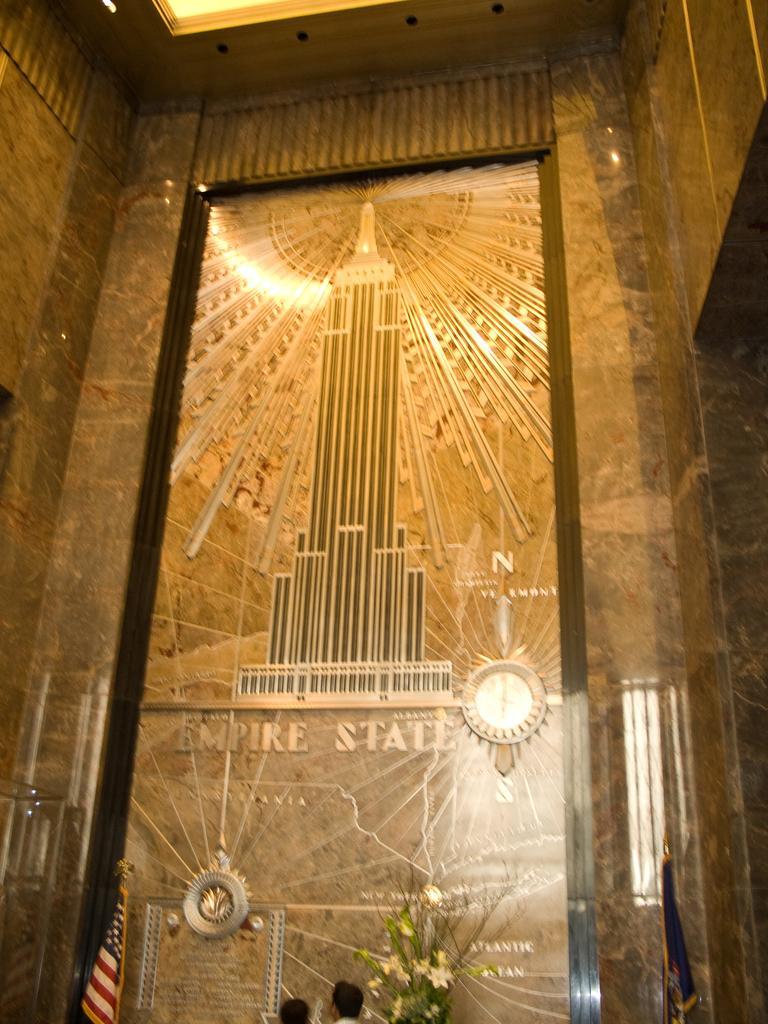Describe this image in one or two sentences. In this picture we can see a wall, on the wall there is a sculpture of a building and there are clock and other objects. At the bottom we can see flags, flower vase and people. 